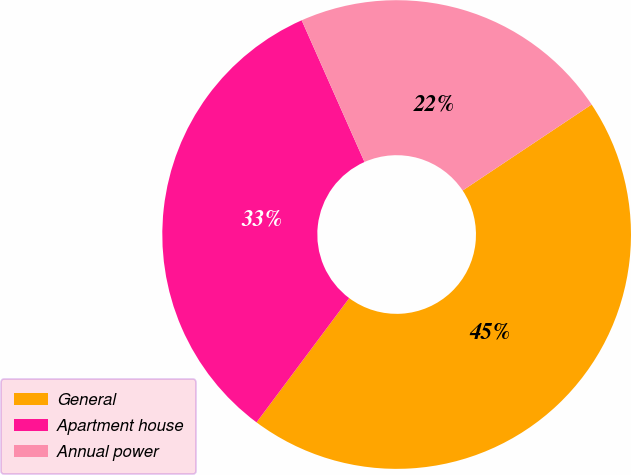Convert chart. <chart><loc_0><loc_0><loc_500><loc_500><pie_chart><fcel>General<fcel>Apartment house<fcel>Annual power<nl><fcel>44.56%<fcel>33.16%<fcel>22.28%<nl></chart> 